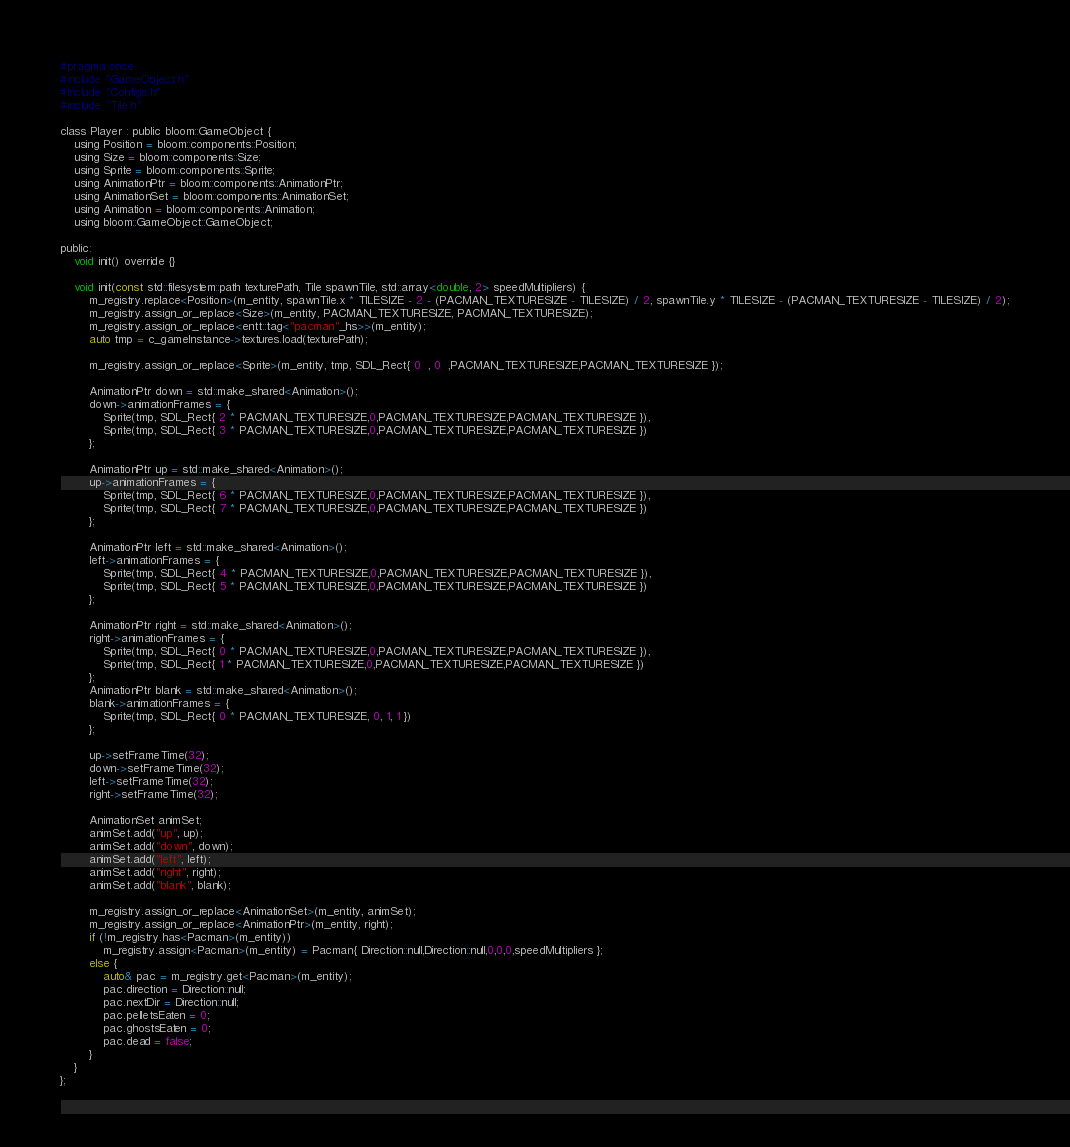<code> <loc_0><loc_0><loc_500><loc_500><_C_>#pragma once
#include "GameObject.h"
#include "Configs.h"
#include "Tile.h"

class Player : public bloom::GameObject {
	using Position = bloom::components::Position;
	using Size = bloom::components::Size;
	using Sprite = bloom::components::Sprite;
	using AnimationPtr = bloom::components::AnimationPtr;
	using AnimationSet = bloom::components::AnimationSet;
	using Animation = bloom::components::Animation;
	using bloom::GameObject::GameObject;

public:
	void init() override {}

	void init(const std::filesystem::path texturePath, Tile spawnTile, std::array<double, 2> speedMultipliers) {
		m_registry.replace<Position>(m_entity, spawnTile.x * TILESIZE - 2 - (PACMAN_TEXTURESIZE - TILESIZE) / 2, spawnTile.y * TILESIZE - (PACMAN_TEXTURESIZE - TILESIZE) / 2);
		m_registry.assign_or_replace<Size>(m_entity, PACMAN_TEXTURESIZE, PACMAN_TEXTURESIZE);
		m_registry.assign_or_replace<entt::tag<"pacman"_hs>>(m_entity);
		auto tmp = c_gameInstance->textures.load(texturePath);

		m_registry.assign_or_replace<Sprite>(m_entity, tmp, SDL_Rect{ 0  , 0  ,PACMAN_TEXTURESIZE,PACMAN_TEXTURESIZE });

		AnimationPtr down = std::make_shared<Animation>();
		down->animationFrames = {
			Sprite(tmp, SDL_Rect{ 2 * PACMAN_TEXTURESIZE,0,PACMAN_TEXTURESIZE,PACMAN_TEXTURESIZE }),
			Sprite(tmp, SDL_Rect{ 3 * PACMAN_TEXTURESIZE,0,PACMAN_TEXTURESIZE,PACMAN_TEXTURESIZE })
		};

		AnimationPtr up = std::make_shared<Animation>();
		up->animationFrames = {
			Sprite(tmp, SDL_Rect{ 6 * PACMAN_TEXTURESIZE,0,PACMAN_TEXTURESIZE,PACMAN_TEXTURESIZE }),
			Sprite(tmp, SDL_Rect{ 7 * PACMAN_TEXTURESIZE,0,PACMAN_TEXTURESIZE,PACMAN_TEXTURESIZE })
		};

		AnimationPtr left = std::make_shared<Animation>();
		left->animationFrames = {
			Sprite(tmp, SDL_Rect{ 4 * PACMAN_TEXTURESIZE,0,PACMAN_TEXTURESIZE,PACMAN_TEXTURESIZE }),
			Sprite(tmp, SDL_Rect{ 5 * PACMAN_TEXTURESIZE,0,PACMAN_TEXTURESIZE,PACMAN_TEXTURESIZE })
		};

		AnimationPtr right = std::make_shared<Animation>();
		right->animationFrames = {
			Sprite(tmp, SDL_Rect{ 0 * PACMAN_TEXTURESIZE,0,PACMAN_TEXTURESIZE,PACMAN_TEXTURESIZE }),
			Sprite(tmp, SDL_Rect{ 1 * PACMAN_TEXTURESIZE,0,PACMAN_TEXTURESIZE,PACMAN_TEXTURESIZE })
		};
		AnimationPtr blank = std::make_shared<Animation>();
		blank->animationFrames = {
			Sprite(tmp, SDL_Rect{ 0 * PACMAN_TEXTURESIZE, 0, 1, 1 })
		};

		up->setFrameTime(32);
		down->setFrameTime(32);
		left->setFrameTime(32);
		right->setFrameTime(32);

		AnimationSet animSet;
		animSet.add("up", up);
		animSet.add("down", down);
		animSet.add("left", left);
		animSet.add("right", right);
		animSet.add("blank", blank);

		m_registry.assign_or_replace<AnimationSet>(m_entity, animSet);
		m_registry.assign_or_replace<AnimationPtr>(m_entity, right);
		if (!m_registry.has<Pacman>(m_entity))
			m_registry.assign<Pacman>(m_entity) = Pacman{ Direction::null,Direction::null,0,0,0,speedMultipliers };
		else {
			auto& pac = m_registry.get<Pacman>(m_entity);
			pac.direction = Direction::null;
			pac.nextDir = Direction::null;
			pac.pelletsEaten = 0;
			pac.ghostsEaten = 0;
			pac.dead = false;
		}
	}
};</code> 